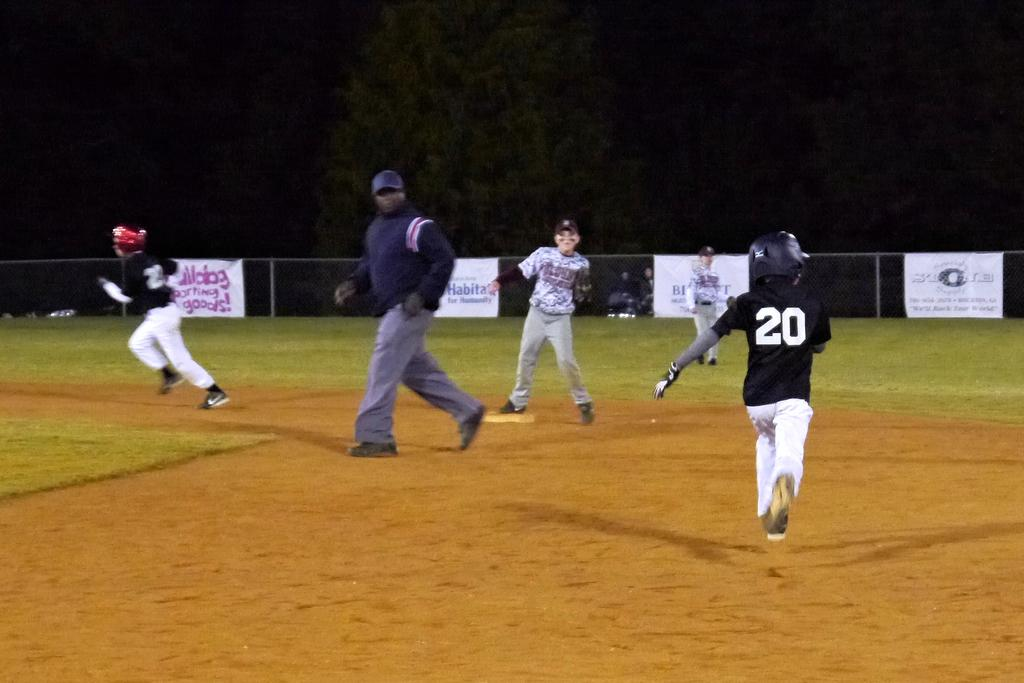<image>
Present a compact description of the photo's key features. A baseball player in a black and white uniform has the number 20 on their back. 